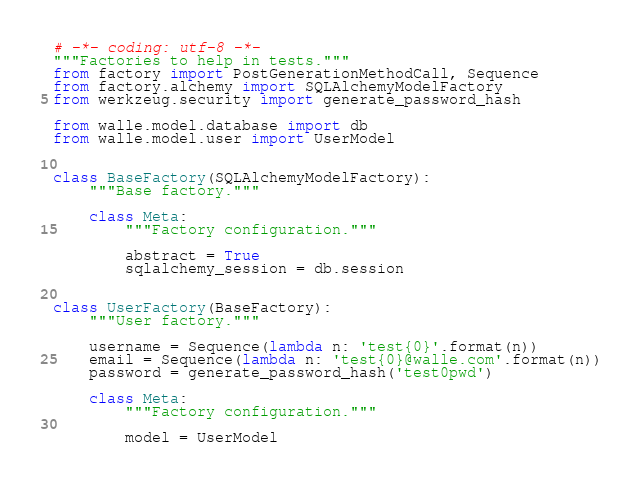<code> <loc_0><loc_0><loc_500><loc_500><_Python_># -*- coding: utf-8 -*-
"""Factories to help in tests."""
from factory import PostGenerationMethodCall, Sequence
from factory.alchemy import SQLAlchemyModelFactory
from werkzeug.security import generate_password_hash

from walle.model.database import db
from walle.model.user import UserModel


class BaseFactory(SQLAlchemyModelFactory):
    """Base factory."""

    class Meta:
        """Factory configuration."""

        abstract = True
        sqlalchemy_session = db.session


class UserFactory(BaseFactory):
    """User factory."""

    username = Sequence(lambda n: 'test{0}'.format(n))
    email = Sequence(lambda n: 'test{0}@walle.com'.format(n))
    password = generate_password_hash('test0pwd')

    class Meta:
        """Factory configuration."""

        model = UserModel
</code> 